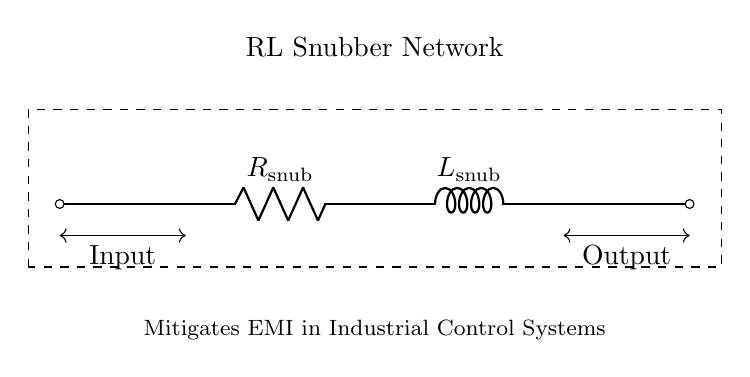What are the components of this circuit? The circuit consists of a resistor and an inductor, as indicated by the symbols R and L in the diagram.
Answer: resistor, inductor What is the function of this RL snubber network? The function of the RL snubber network is to mitigate electromagnetic interference by providing a path for high-frequency noise to dissipate, reducing voltage spikes.
Answer: mitigate electromagnetic interference What is the component value labeled as R in the circuit? The component labeled as R in the circuit is the resistor, identified as R snub, which is part of the snubber network.
Answer: R snub How does the inductor influence the circuit behavior? The inductor opposes changes in current, which helps to smooth out voltage spikes and limits the rate of current change, thus reducing EMI.
Answer: smooth out voltage spikes What happens when the input voltage increases rapidly? When the input voltage increases rapidly, the inductor delays the increase in current, preventing sudden changes and helping to stabilize the circuit operation.
Answer: stabilizes circuit operation What is the relationship between the resistor and inductor in this circuit? The resistor and inductor are in series, meaning they share the same current but affect the voltage across the snubber network differently, with the resistor dissipating energy as heat.
Answer: in series How does this RL snubber network improve the reliability of industrial control systems? The RL snubber network improves reliability by reducing the effects of voltage transients and electrical noise, which can lead to system failures or erroneous operations in control systems.
Answer: reduces voltage transients 